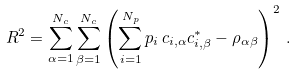Convert formula to latex. <formula><loc_0><loc_0><loc_500><loc_500>R ^ { 2 } = \sum _ { \alpha = 1 } ^ { N _ { c } } \sum _ { \beta = 1 } ^ { N _ { c } } \left ( \sum _ { i = 1 } ^ { N _ { p } } p _ { i } \, c _ { i , \alpha } c ^ { * } _ { i , \beta } - \rho _ { \alpha \beta } \right ) ^ { 2 } \, .</formula> 